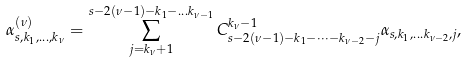<formula> <loc_0><loc_0><loc_500><loc_500>\alpha _ { s , k _ { 1 } , \dots , k _ { \nu } } ^ { ( \nu ) } = \sum _ { j = k _ { \nu } + 1 } ^ { s - 2 ( \nu - 1 ) - k _ { 1 } - \dots k _ { \nu - 1 } } C _ { s - 2 ( \nu - 1 ) - k _ { 1 } - \dots - k _ { \nu - 2 } - j } ^ { k _ { \nu } - 1 } \alpha _ { s , k _ { 1 } , \dots k _ { \nu - 2 } , j } , \,</formula> 